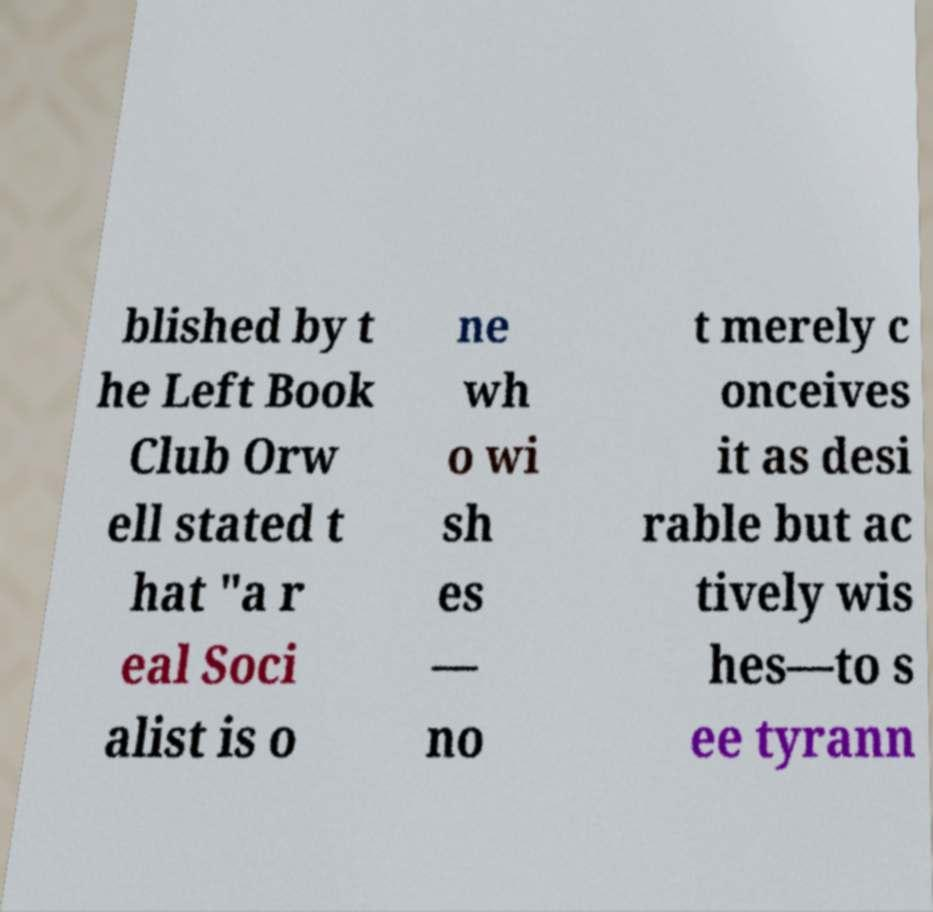What messages or text are displayed in this image? I need them in a readable, typed format. blished by t he Left Book Club Orw ell stated t hat "a r eal Soci alist is o ne wh o wi sh es — no t merely c onceives it as desi rable but ac tively wis hes—to s ee tyrann 